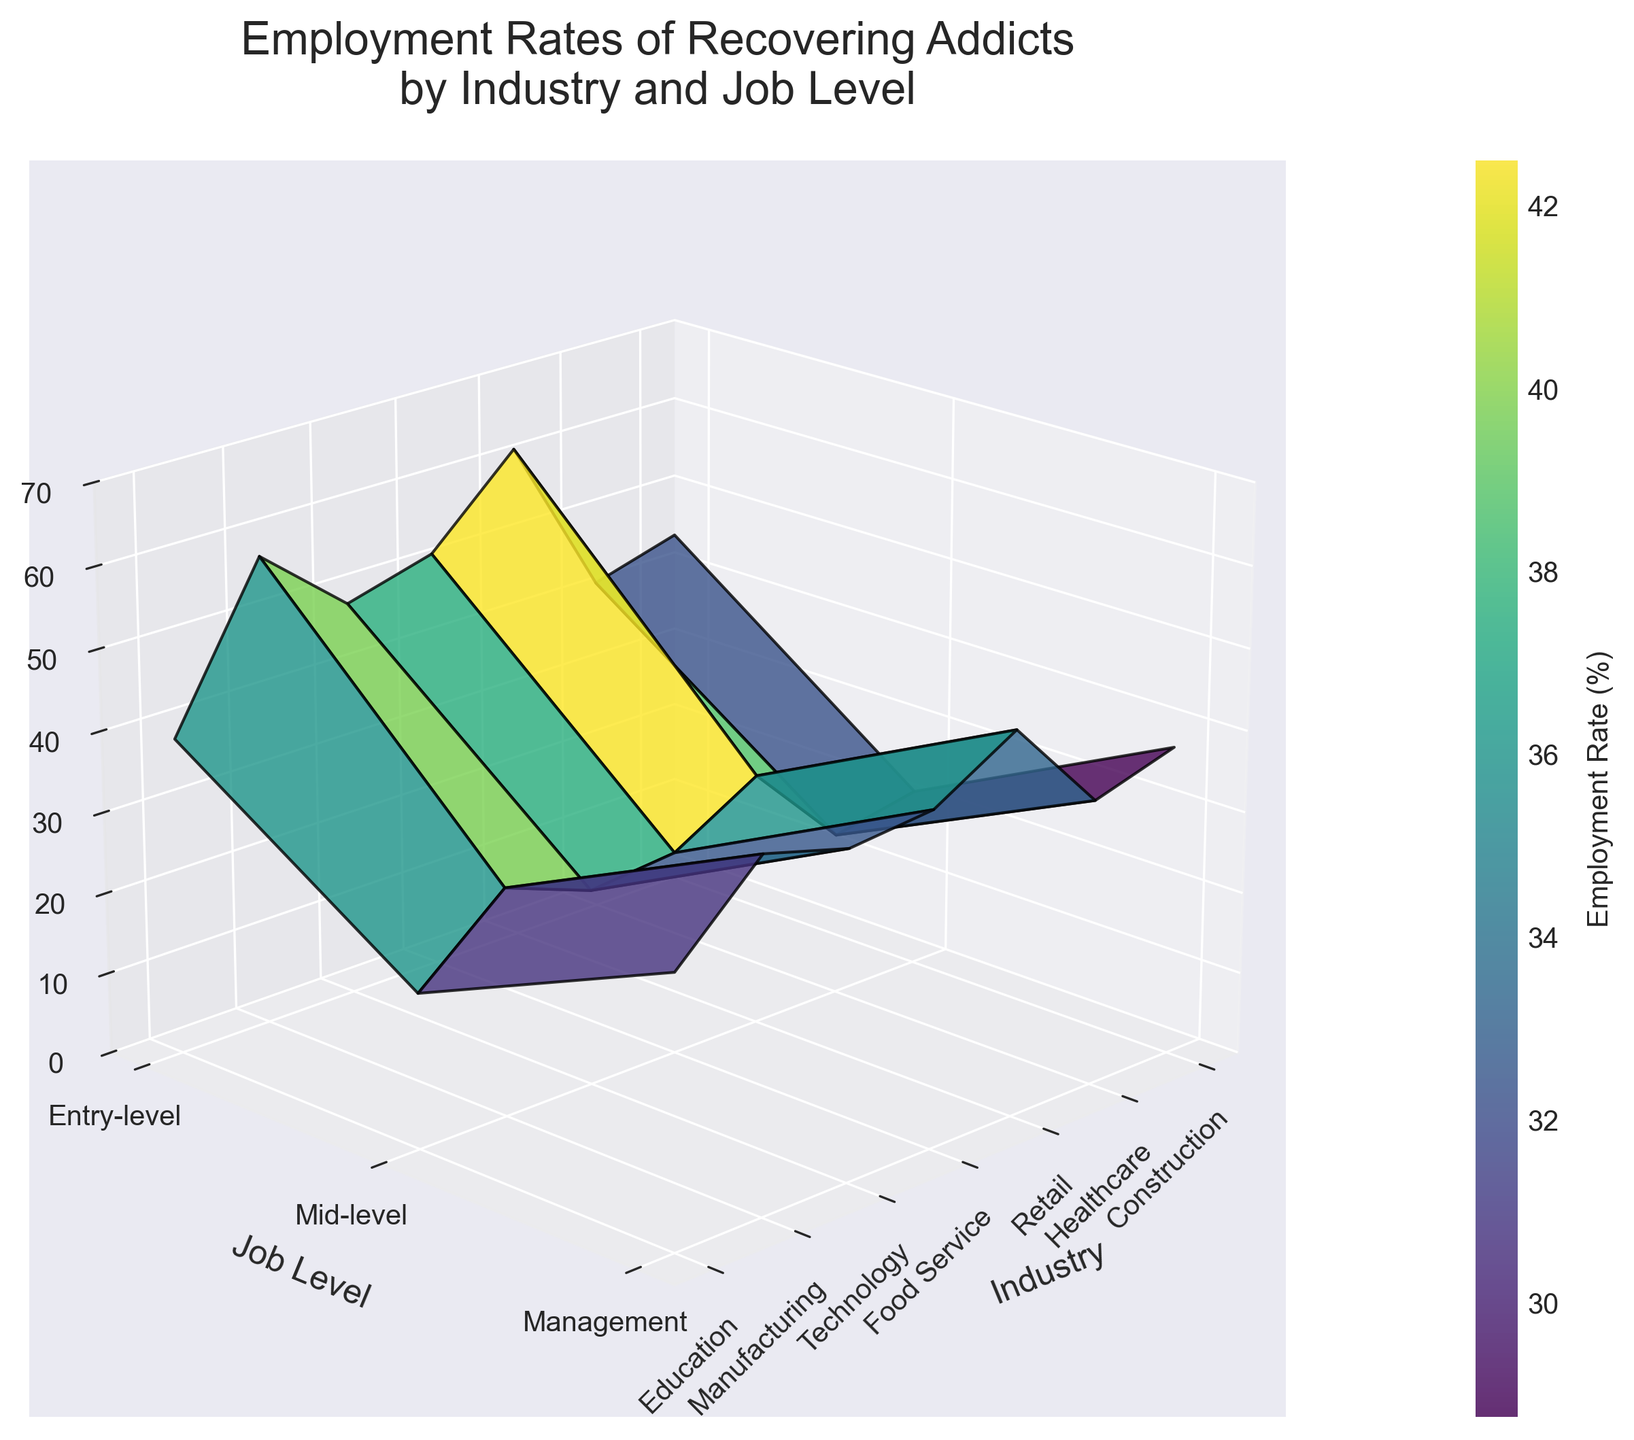What's the title of the figure? The title is displayed at the top center of the figure and provides a summary of what the plot represents.
Answer: Employment Rates of Recovering Addicts by Industry and Job Level How many industries are shown in the figure? Count the number of distinct industry names on the x-axis or legend.
Answer: 7 Which industry has the highest employment rate for entry-level jobs? Look at the entry-level section of the z-axis across all industries and find the maximum value.
Answer: Food Service What is the employment rate for mid-level positions in the Technology sector? Locate the intersection of the Technology sector on the x-axis and mid-level positions on the y-axis, then read the z-axis value.
Answer: 33% Which job level generally shows the lowest employment rates across all industries? Compare the z-axis values for entry-level, mid-level, and management levels across all industries and identify the lowest range.
Answer: Management How does the employment rate for management in the Healthcare industry compare to management in the Retail industry? Look at the intersection of the management level and their respective industries on the z-axis and compare the values.
Answer: Healthcare (25%) is lower than Retail (28%) What is the difference in employment rates between entry-level and mid-level positions in the Construction industry? Subtract the mid-level employment rate from the entry-level employment rate in the Construction sector.
Answer: 45% - 38% = 7% On average, which job level has the highest employment rate? Calculate the average employment rate for each job level across all industries and compare the results.
Answer: Entry-level What is the employment rate range observed in the plot? Identify the minimum and maximum employment rate values on the z-axis.
Answer: 19% to 62% In which industry and job level combination is the employment rate the lowest? Scan across all industry and job level combinations and identify the minimum value on the z-axis.
Answer: Technology, Management (19%) 